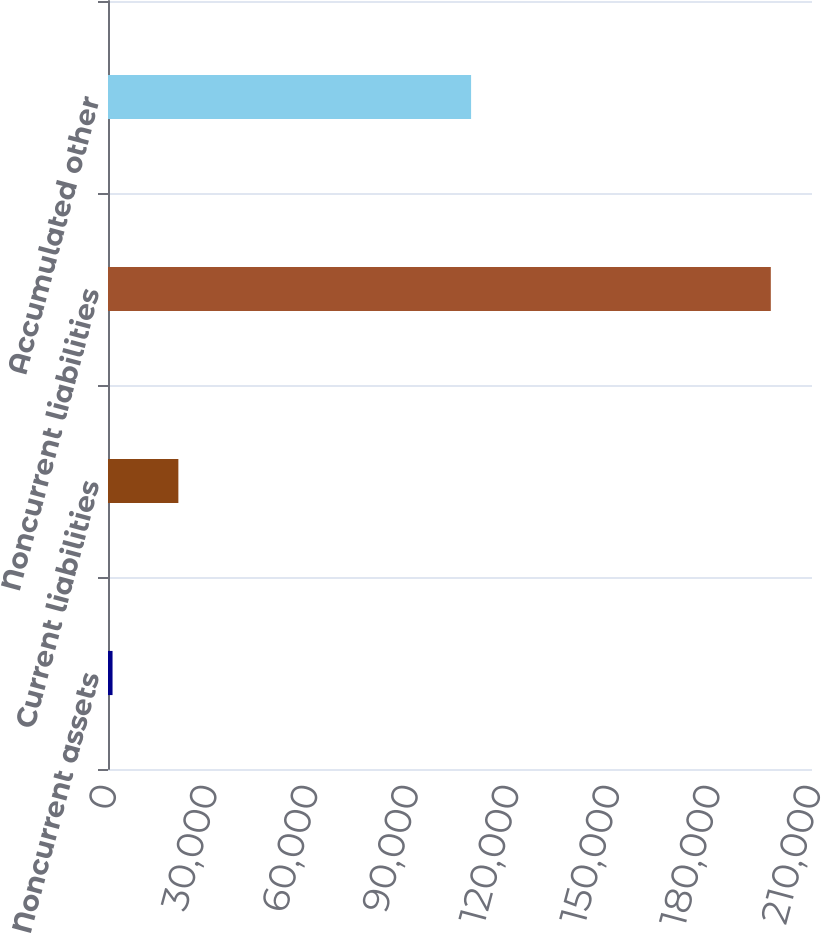Convert chart to OTSL. <chart><loc_0><loc_0><loc_500><loc_500><bar_chart><fcel>Noncurrent assets<fcel>Current liabilities<fcel>Noncurrent liabilities<fcel>Accumulated other<nl><fcel>1355<fcel>20991<fcel>197715<fcel>108310<nl></chart> 